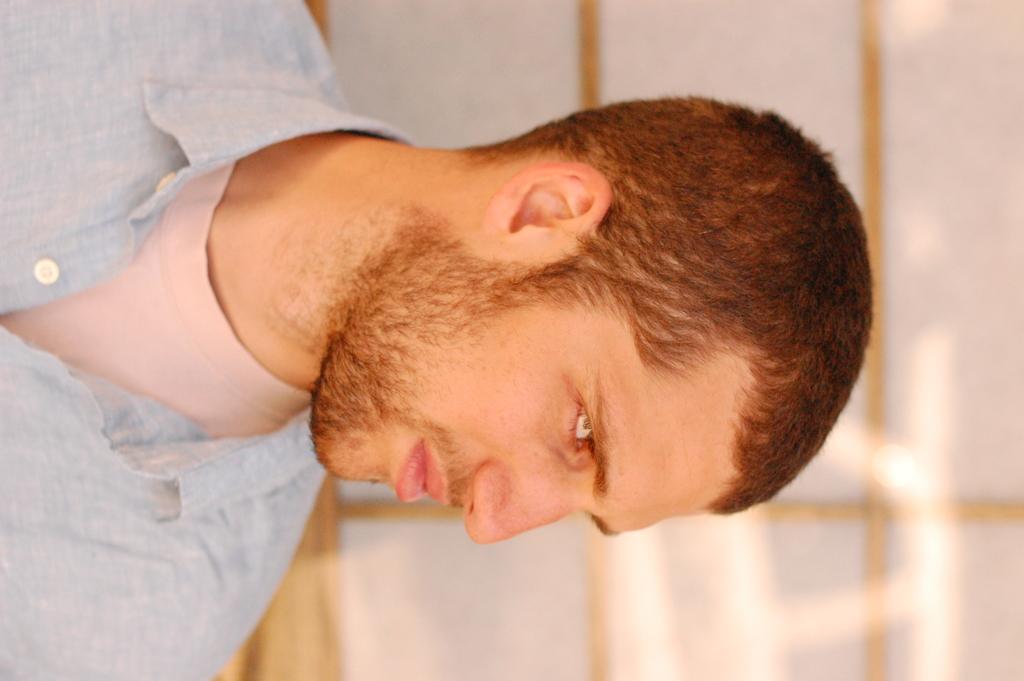Describe this image in one or two sentences. Here in this picture we can see a person present over there. 